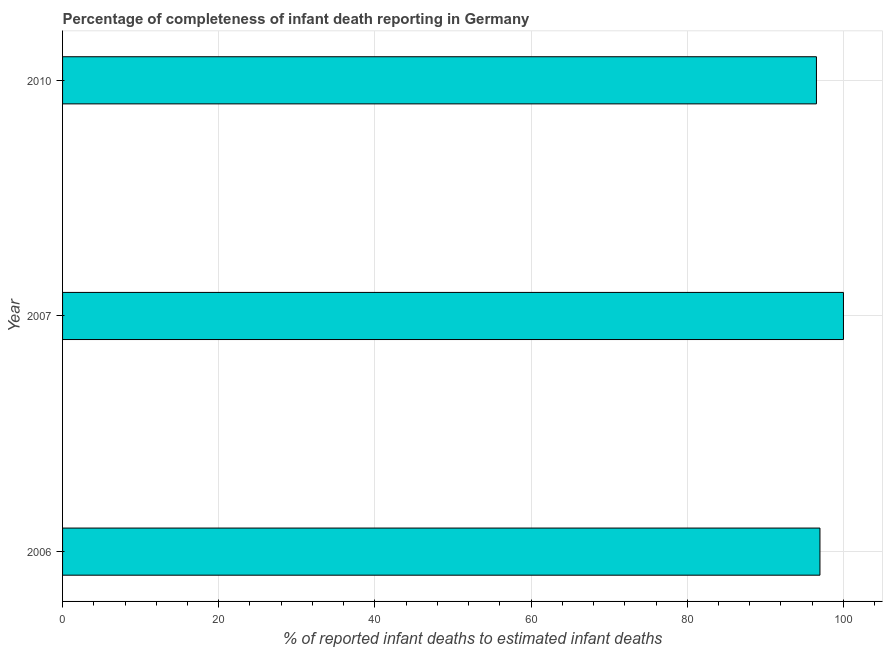Does the graph contain any zero values?
Make the answer very short. No. Does the graph contain grids?
Ensure brevity in your answer.  Yes. What is the title of the graph?
Make the answer very short. Percentage of completeness of infant death reporting in Germany. What is the label or title of the X-axis?
Make the answer very short. % of reported infant deaths to estimated infant deaths. What is the label or title of the Y-axis?
Provide a short and direct response. Year. What is the completeness of infant death reporting in 2010?
Ensure brevity in your answer.  96.54. Across all years, what is the maximum completeness of infant death reporting?
Provide a succinct answer. 100. Across all years, what is the minimum completeness of infant death reporting?
Your answer should be very brief. 96.54. What is the sum of the completeness of infant death reporting?
Offer a very short reply. 293.53. What is the difference between the completeness of infant death reporting in 2007 and 2010?
Provide a short and direct response. 3.46. What is the average completeness of infant death reporting per year?
Offer a terse response. 97.84. What is the median completeness of infant death reporting?
Offer a terse response. 96.99. What is the ratio of the completeness of infant death reporting in 2006 to that in 2007?
Provide a short and direct response. 0.97. Is the difference between the completeness of infant death reporting in 2007 and 2010 greater than the difference between any two years?
Ensure brevity in your answer.  Yes. What is the difference between the highest and the second highest completeness of infant death reporting?
Make the answer very short. 3.01. Is the sum of the completeness of infant death reporting in 2006 and 2010 greater than the maximum completeness of infant death reporting across all years?
Your answer should be very brief. Yes. What is the difference between the highest and the lowest completeness of infant death reporting?
Provide a short and direct response. 3.46. In how many years, is the completeness of infant death reporting greater than the average completeness of infant death reporting taken over all years?
Your answer should be compact. 1. How many bars are there?
Your answer should be very brief. 3. Are the values on the major ticks of X-axis written in scientific E-notation?
Make the answer very short. No. What is the % of reported infant deaths to estimated infant deaths of 2006?
Your answer should be compact. 96.99. What is the % of reported infant deaths to estimated infant deaths in 2007?
Ensure brevity in your answer.  100. What is the % of reported infant deaths to estimated infant deaths of 2010?
Keep it short and to the point. 96.54. What is the difference between the % of reported infant deaths to estimated infant deaths in 2006 and 2007?
Make the answer very short. -3.01. What is the difference between the % of reported infant deaths to estimated infant deaths in 2006 and 2010?
Offer a terse response. 0.45. What is the difference between the % of reported infant deaths to estimated infant deaths in 2007 and 2010?
Offer a very short reply. 3.46. What is the ratio of the % of reported infant deaths to estimated infant deaths in 2006 to that in 2007?
Your answer should be compact. 0.97. What is the ratio of the % of reported infant deaths to estimated infant deaths in 2006 to that in 2010?
Provide a short and direct response. 1. What is the ratio of the % of reported infant deaths to estimated infant deaths in 2007 to that in 2010?
Offer a terse response. 1.04. 